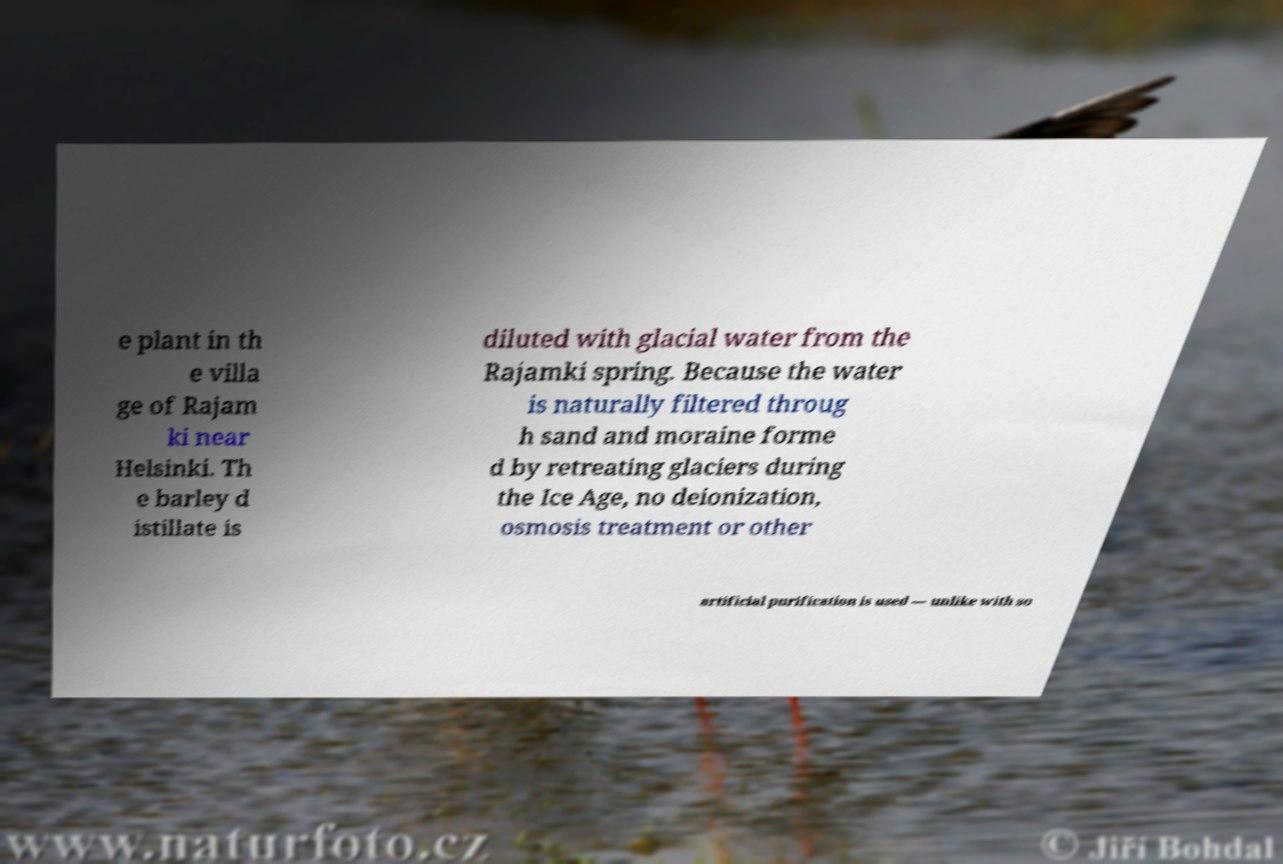Please read and relay the text visible in this image. What does it say? e plant in th e villa ge of Rajam ki near Helsinki. Th e barley d istillate is diluted with glacial water from the Rajamki spring. Because the water is naturally filtered throug h sand and moraine forme d by retreating glaciers during the Ice Age, no deionization, osmosis treatment or other artificial purification is used — unlike with so 